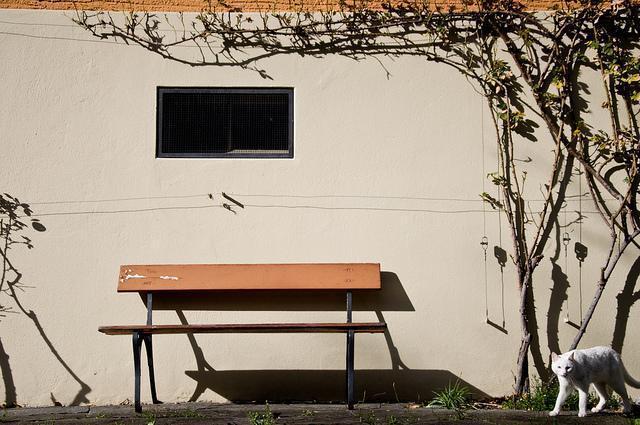How many benches are there?
Give a very brief answer. 1. How many dark umbrellas are there?
Give a very brief answer. 0. 